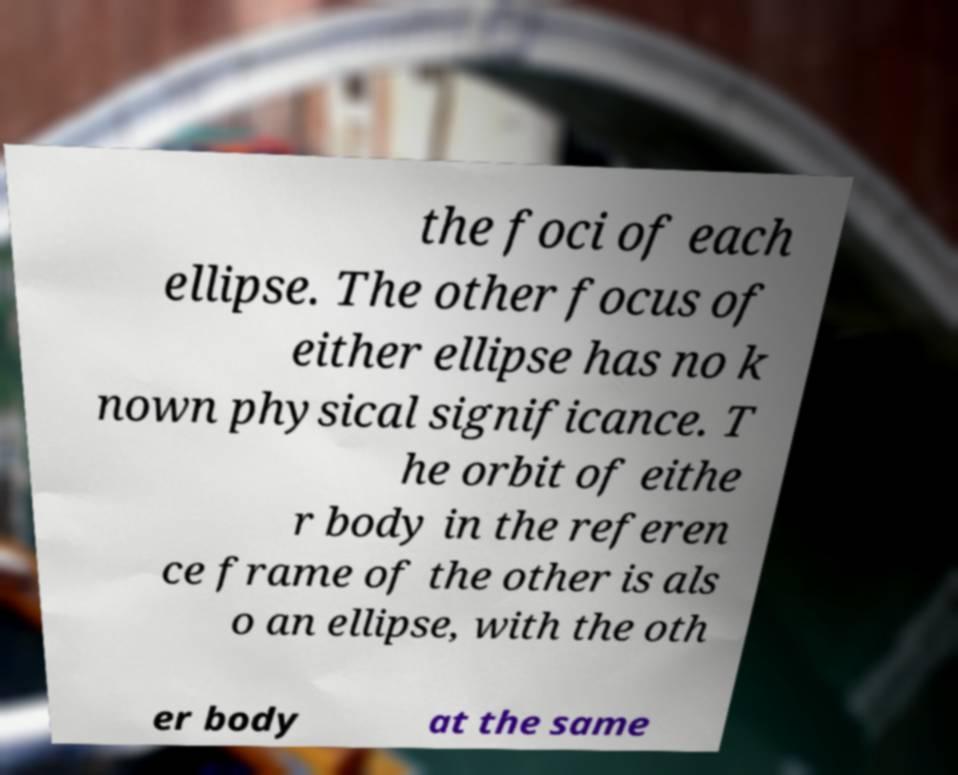Please identify and transcribe the text found in this image. the foci of each ellipse. The other focus of either ellipse has no k nown physical significance. T he orbit of eithe r body in the referen ce frame of the other is als o an ellipse, with the oth er body at the same 